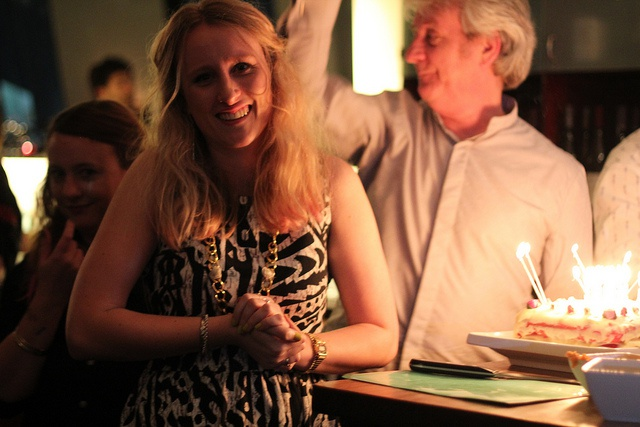Describe the objects in this image and their specific colors. I can see people in black, maroon, tan, and brown tones, people in black, tan, salmon, and brown tones, people in black, maroon, and olive tones, dining table in black, tan, khaki, and maroon tones, and cake in black, ivory, tan, khaki, and salmon tones in this image. 